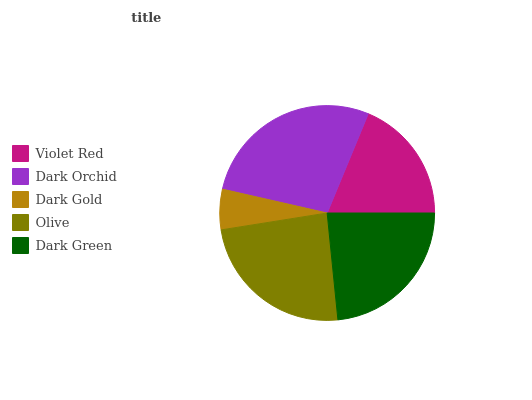Is Dark Gold the minimum?
Answer yes or no. Yes. Is Dark Orchid the maximum?
Answer yes or no. Yes. Is Dark Orchid the minimum?
Answer yes or no. No. Is Dark Gold the maximum?
Answer yes or no. No. Is Dark Orchid greater than Dark Gold?
Answer yes or no. Yes. Is Dark Gold less than Dark Orchid?
Answer yes or no. Yes. Is Dark Gold greater than Dark Orchid?
Answer yes or no. No. Is Dark Orchid less than Dark Gold?
Answer yes or no. No. Is Dark Green the high median?
Answer yes or no. Yes. Is Dark Green the low median?
Answer yes or no. Yes. Is Olive the high median?
Answer yes or no. No. Is Dark Gold the low median?
Answer yes or no. No. 